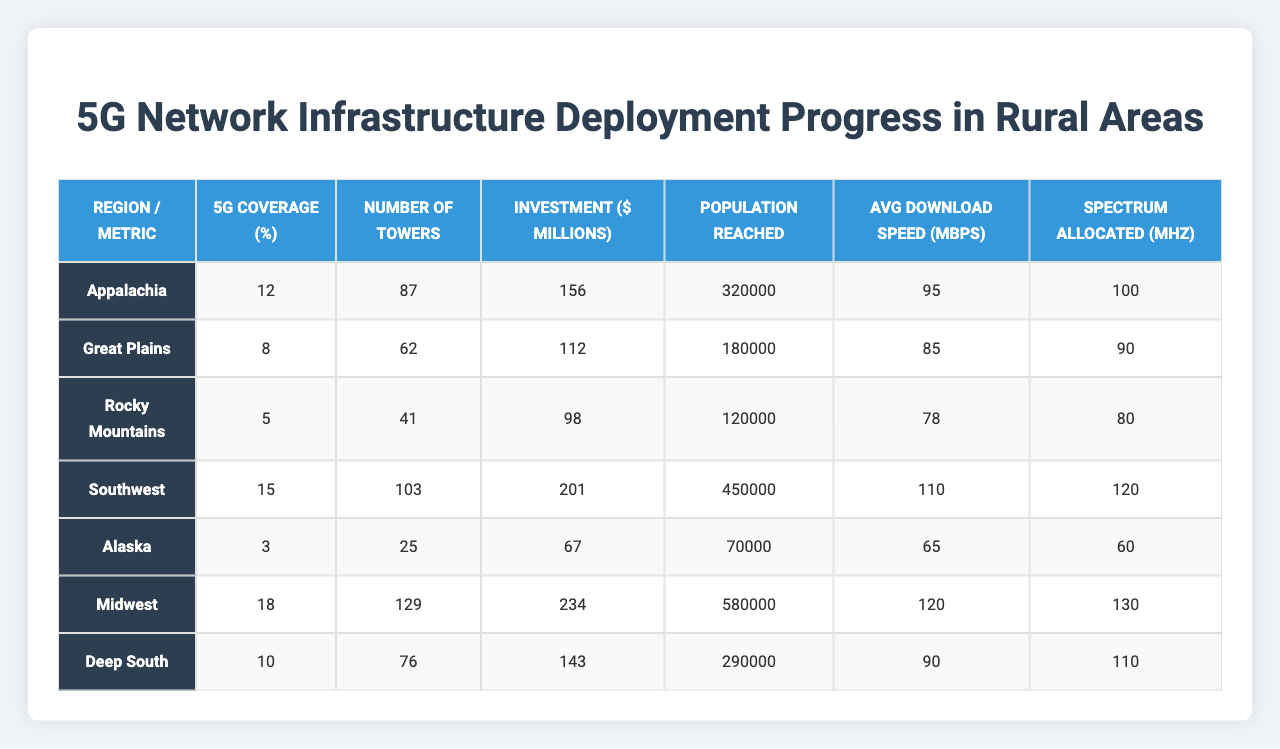What is the 5G coverage percentage in the Midwest? The table lists the 5G coverage for each region, and for the Midwest, it shows 18%.
Answer: 18% Which region has the highest number of 5G towers? By looking at the "Number of Towers" column, we can see that the Midwest has the highest count with 129 towers.
Answer: Midwest What is the total investment made in 5G infrastructure for Alaska and the Southwest combined? To find this, we add the investments for Alaska ($67 million) and the Southwest ($201 million): 67 + 201 = 268 million.
Answer: 268 million What is the average download speed across all regions? The download speeds are 95, 85, 78, 110, 65, 120, and 90 Mbps respectively. Adding these gives 95 + 85 + 78 + 110 + 65 + 120 + 90 = 743 and dividing by 7 regions gives an average of 106.14 Mbps.
Answer: 106.14 Mbps Is the population reached in the Deep South greater than that in Alaska? The population reached in the Deep South is 290,000, while in Alaska, it is 70,000. Since 290,000 is greater than 70,000, the statement is true.
Answer: Yes Which region shows the best average download speed and how much is it? The table indicates the average download speeds per region, with the Midwest showing the highest speed of 120 Mbps.
Answer: Midwest, 120 Mbps How many MHz of spectrum is allocated in the Rocky Mountains? Looking at the "Spectrum Allocated (MHz)" row, the Rocky Mountains is allocated 80 MHz.
Answer: 80 MHz If the number of 5G towers in the Great Plains were to increase by 20%, how many towers would that be? The current number of towers in the Great Plains is 62. Increasing by 20% means calculating 62 + (0.2 * 62) = 62 + 12.4 = 74.4, which rounds down to 74 towers.
Answer: 74 towers What percentage of the population reached in the Southwest as compared to the Deep South? The population reached in the Southwest is 450,000 and in the Deep South is 290,000. To find the percentage of the Deep South population compared to the Southwest: (290,000 / 450,000) * 100 = 64.44%.
Answer: 64.44% Which region has the least amount of investment, and how much is it? The investments are represented in millions and for Alaska, it shows the least with $67 million.
Answer: Alaska, $67 million 